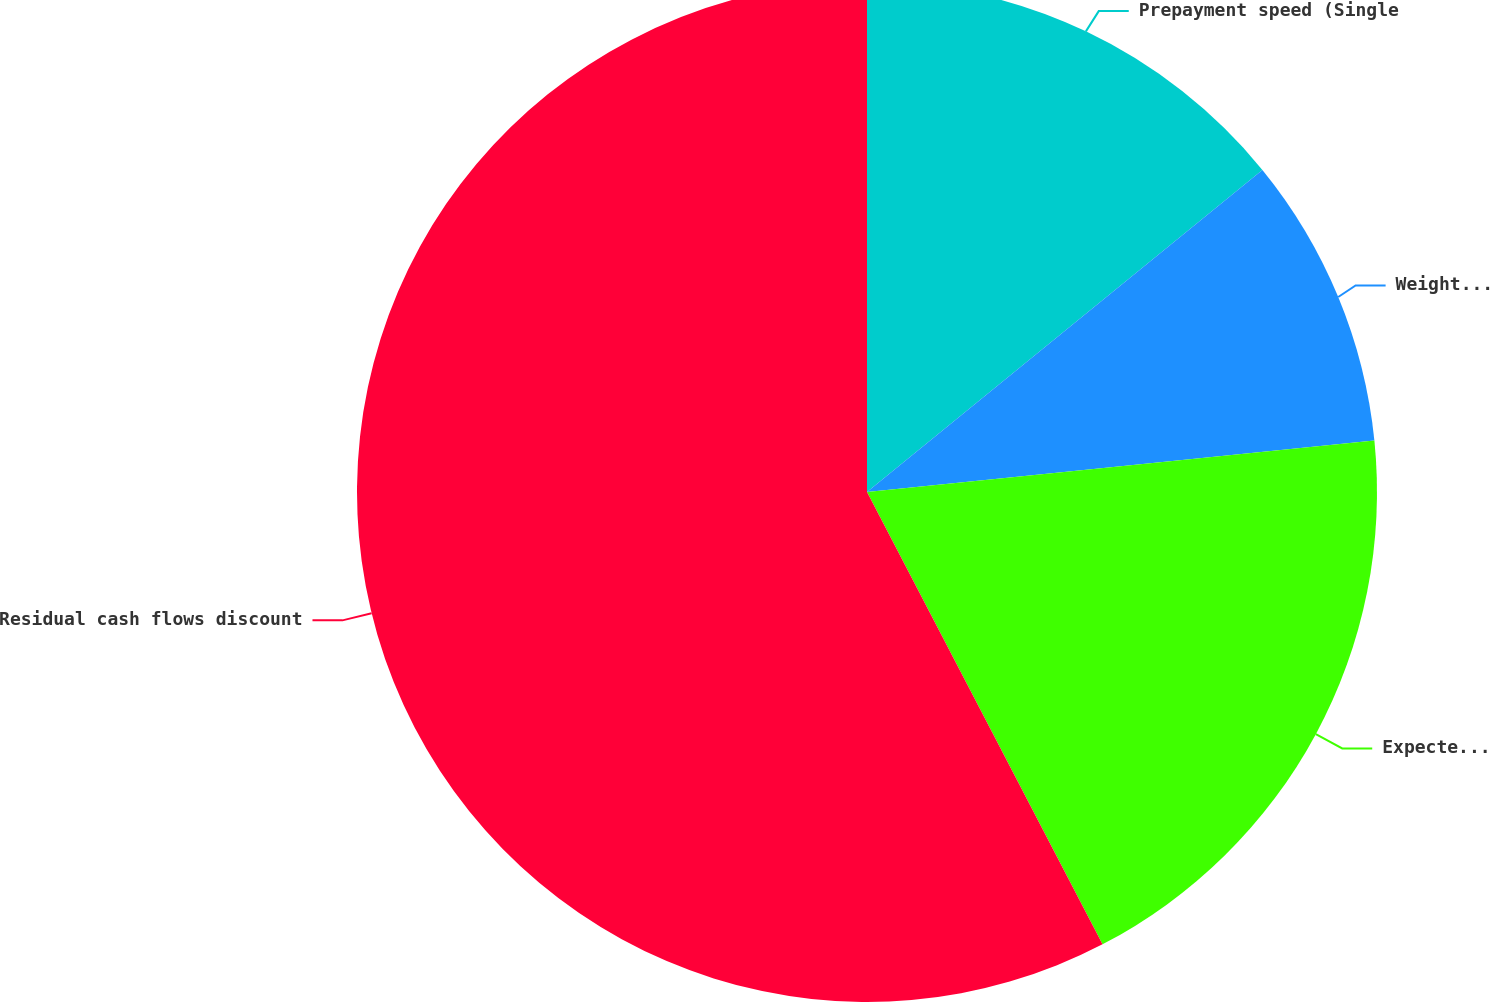Convert chart to OTSL. <chart><loc_0><loc_0><loc_500><loc_500><pie_chart><fcel>Prepayment speed (Single<fcel>Weighted-average life (in<fcel>Expected cumulative net credit<fcel>Residual cash flows discount<nl><fcel>14.12%<fcel>9.27%<fcel>18.97%<fcel>57.64%<nl></chart> 